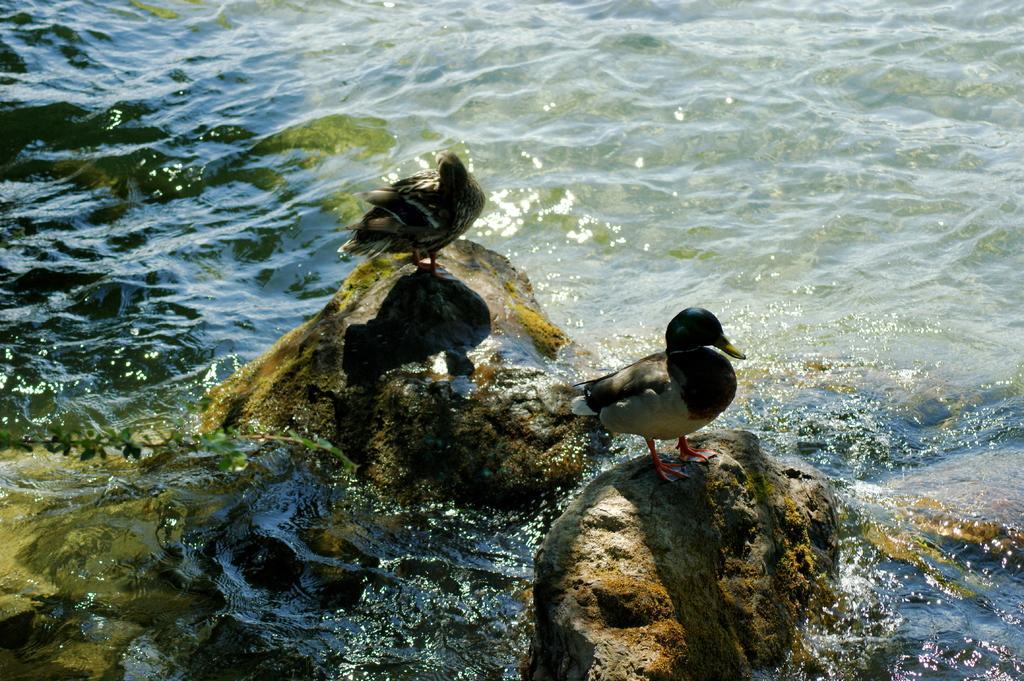Please provide a concise description of this image. In the picture we can see water in it we can see two stones and on it we can see two ducks are standing and which are some part white, black and yellow beak. 